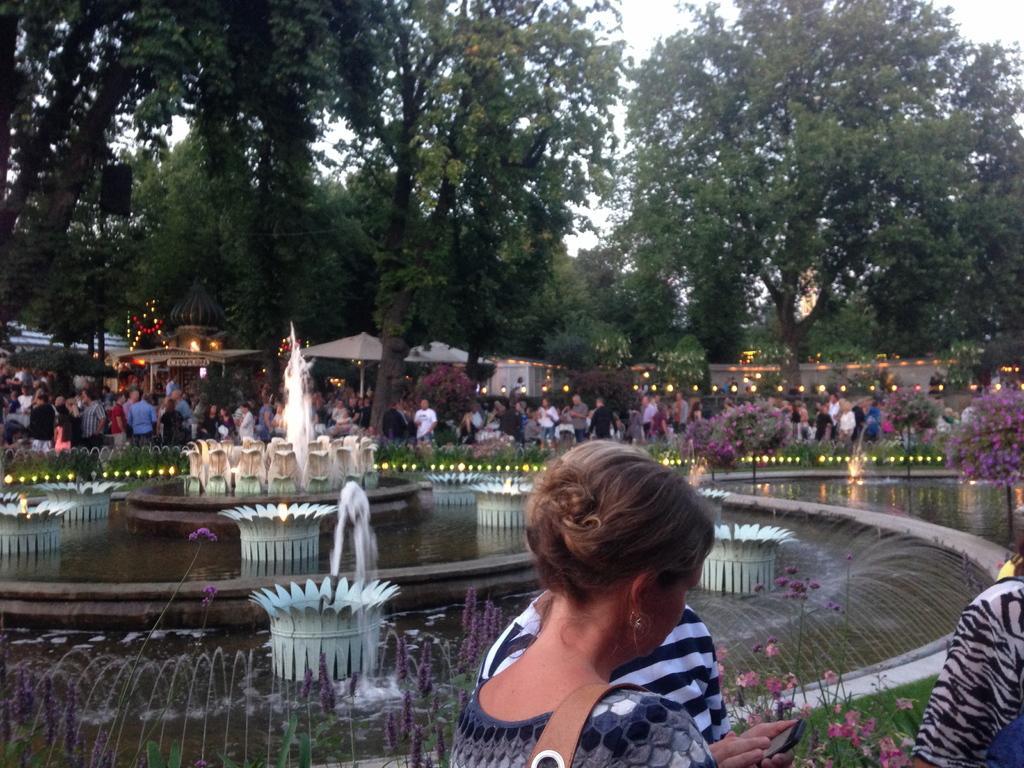Describe this image in one or two sentences. In this picture I can see the three persons at the bottom, in the middle there are fountains in the background. I can see few people, tents, houses with lights and trees. At the top there is the sky. 